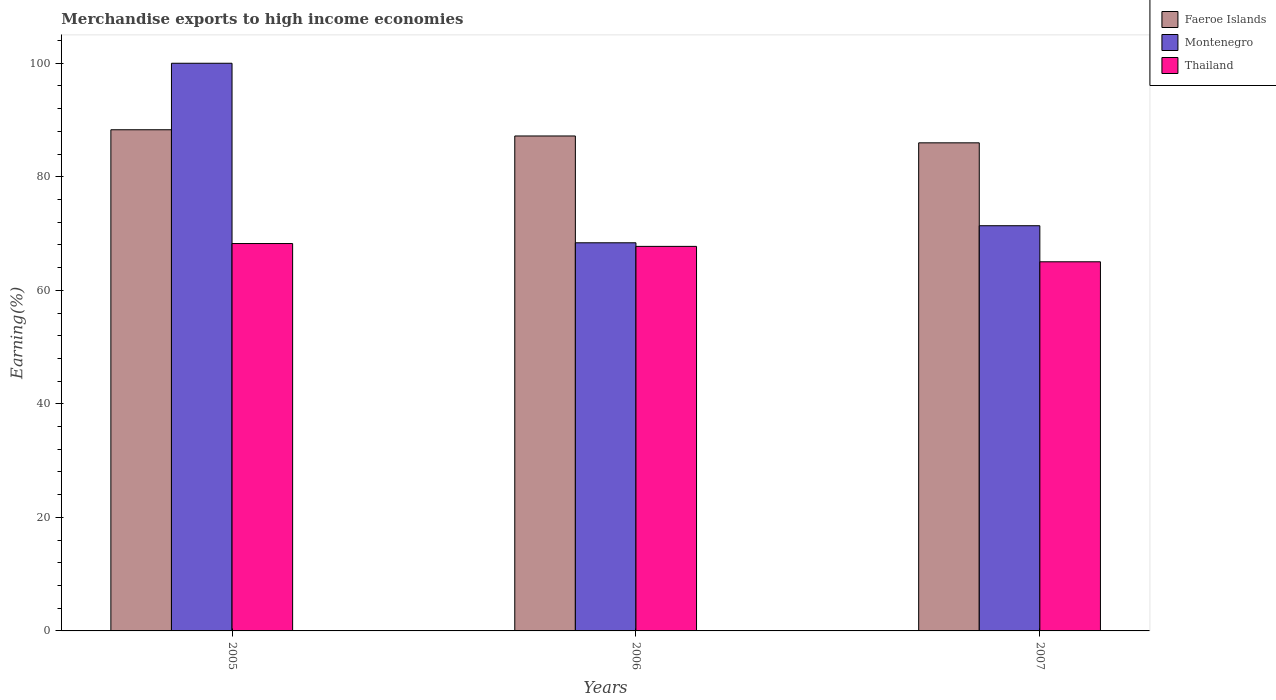How many groups of bars are there?
Keep it short and to the point. 3. What is the label of the 3rd group of bars from the left?
Offer a very short reply. 2007. In how many cases, is the number of bars for a given year not equal to the number of legend labels?
Offer a very short reply. 0. What is the percentage of amount earned from merchandise exports in Montenegro in 2005?
Offer a terse response. 100. Across all years, what is the maximum percentage of amount earned from merchandise exports in Faeroe Islands?
Ensure brevity in your answer.  88.29. Across all years, what is the minimum percentage of amount earned from merchandise exports in Montenegro?
Your answer should be very brief. 68.37. In which year was the percentage of amount earned from merchandise exports in Thailand maximum?
Offer a very short reply. 2005. In which year was the percentage of amount earned from merchandise exports in Faeroe Islands minimum?
Provide a succinct answer. 2007. What is the total percentage of amount earned from merchandise exports in Faeroe Islands in the graph?
Your answer should be very brief. 261.46. What is the difference between the percentage of amount earned from merchandise exports in Thailand in 2005 and that in 2007?
Your answer should be compact. 3.22. What is the difference between the percentage of amount earned from merchandise exports in Faeroe Islands in 2005 and the percentage of amount earned from merchandise exports in Montenegro in 2006?
Give a very brief answer. 19.91. What is the average percentage of amount earned from merchandise exports in Montenegro per year?
Offer a very short reply. 79.92. In the year 2006, what is the difference between the percentage of amount earned from merchandise exports in Montenegro and percentage of amount earned from merchandise exports in Thailand?
Your response must be concise. 0.63. What is the ratio of the percentage of amount earned from merchandise exports in Thailand in 2006 to that in 2007?
Your answer should be very brief. 1.04. Is the difference between the percentage of amount earned from merchandise exports in Montenegro in 2006 and 2007 greater than the difference between the percentage of amount earned from merchandise exports in Thailand in 2006 and 2007?
Keep it short and to the point. No. What is the difference between the highest and the second highest percentage of amount earned from merchandise exports in Faeroe Islands?
Provide a succinct answer. 1.1. What is the difference between the highest and the lowest percentage of amount earned from merchandise exports in Faeroe Islands?
Your answer should be very brief. 2.3. What does the 3rd bar from the left in 2007 represents?
Your answer should be compact. Thailand. What does the 3rd bar from the right in 2007 represents?
Offer a terse response. Faeroe Islands. How many bars are there?
Offer a very short reply. 9. What is the difference between two consecutive major ticks on the Y-axis?
Provide a short and direct response. 20. Are the values on the major ticks of Y-axis written in scientific E-notation?
Make the answer very short. No. Does the graph contain any zero values?
Your answer should be very brief. No. Where does the legend appear in the graph?
Your answer should be very brief. Top right. How many legend labels are there?
Make the answer very short. 3. What is the title of the graph?
Your answer should be compact. Merchandise exports to high income economies. What is the label or title of the Y-axis?
Your answer should be compact. Earning(%). What is the Earning(%) of Faeroe Islands in 2005?
Ensure brevity in your answer.  88.29. What is the Earning(%) in Montenegro in 2005?
Offer a very short reply. 100. What is the Earning(%) in Thailand in 2005?
Offer a very short reply. 68.24. What is the Earning(%) in Faeroe Islands in 2006?
Your answer should be very brief. 87.19. What is the Earning(%) of Montenegro in 2006?
Keep it short and to the point. 68.37. What is the Earning(%) in Thailand in 2006?
Offer a very short reply. 67.74. What is the Earning(%) in Faeroe Islands in 2007?
Your answer should be compact. 85.98. What is the Earning(%) in Montenegro in 2007?
Provide a succinct answer. 71.38. What is the Earning(%) in Thailand in 2007?
Give a very brief answer. 65.03. Across all years, what is the maximum Earning(%) of Faeroe Islands?
Keep it short and to the point. 88.29. Across all years, what is the maximum Earning(%) in Montenegro?
Your response must be concise. 100. Across all years, what is the maximum Earning(%) of Thailand?
Make the answer very short. 68.24. Across all years, what is the minimum Earning(%) in Faeroe Islands?
Offer a terse response. 85.98. Across all years, what is the minimum Earning(%) in Montenegro?
Offer a very short reply. 68.37. Across all years, what is the minimum Earning(%) of Thailand?
Your answer should be very brief. 65.03. What is the total Earning(%) of Faeroe Islands in the graph?
Offer a very short reply. 261.46. What is the total Earning(%) in Montenegro in the graph?
Your answer should be compact. 239.75. What is the total Earning(%) in Thailand in the graph?
Offer a very short reply. 201.01. What is the difference between the Earning(%) of Faeroe Islands in 2005 and that in 2006?
Your response must be concise. 1.1. What is the difference between the Earning(%) in Montenegro in 2005 and that in 2006?
Your response must be concise. 31.63. What is the difference between the Earning(%) of Thailand in 2005 and that in 2006?
Keep it short and to the point. 0.5. What is the difference between the Earning(%) of Faeroe Islands in 2005 and that in 2007?
Provide a short and direct response. 2.3. What is the difference between the Earning(%) in Montenegro in 2005 and that in 2007?
Provide a succinct answer. 28.62. What is the difference between the Earning(%) in Thailand in 2005 and that in 2007?
Provide a succinct answer. 3.22. What is the difference between the Earning(%) of Faeroe Islands in 2006 and that in 2007?
Provide a succinct answer. 1.21. What is the difference between the Earning(%) in Montenegro in 2006 and that in 2007?
Offer a very short reply. -3.01. What is the difference between the Earning(%) in Thailand in 2006 and that in 2007?
Make the answer very short. 2.72. What is the difference between the Earning(%) in Faeroe Islands in 2005 and the Earning(%) in Montenegro in 2006?
Your answer should be very brief. 19.91. What is the difference between the Earning(%) of Faeroe Islands in 2005 and the Earning(%) of Thailand in 2006?
Give a very brief answer. 20.54. What is the difference between the Earning(%) of Montenegro in 2005 and the Earning(%) of Thailand in 2006?
Provide a succinct answer. 32.26. What is the difference between the Earning(%) of Faeroe Islands in 2005 and the Earning(%) of Montenegro in 2007?
Your answer should be very brief. 16.91. What is the difference between the Earning(%) of Faeroe Islands in 2005 and the Earning(%) of Thailand in 2007?
Provide a succinct answer. 23.26. What is the difference between the Earning(%) in Montenegro in 2005 and the Earning(%) in Thailand in 2007?
Make the answer very short. 34.97. What is the difference between the Earning(%) in Faeroe Islands in 2006 and the Earning(%) in Montenegro in 2007?
Ensure brevity in your answer.  15.81. What is the difference between the Earning(%) in Faeroe Islands in 2006 and the Earning(%) in Thailand in 2007?
Give a very brief answer. 22.16. What is the difference between the Earning(%) in Montenegro in 2006 and the Earning(%) in Thailand in 2007?
Give a very brief answer. 3.35. What is the average Earning(%) of Faeroe Islands per year?
Offer a terse response. 87.15. What is the average Earning(%) in Montenegro per year?
Your answer should be very brief. 79.92. What is the average Earning(%) of Thailand per year?
Make the answer very short. 67. In the year 2005, what is the difference between the Earning(%) of Faeroe Islands and Earning(%) of Montenegro?
Make the answer very short. -11.71. In the year 2005, what is the difference between the Earning(%) in Faeroe Islands and Earning(%) in Thailand?
Give a very brief answer. 20.04. In the year 2005, what is the difference between the Earning(%) in Montenegro and Earning(%) in Thailand?
Offer a terse response. 31.76. In the year 2006, what is the difference between the Earning(%) of Faeroe Islands and Earning(%) of Montenegro?
Offer a very short reply. 18.82. In the year 2006, what is the difference between the Earning(%) in Faeroe Islands and Earning(%) in Thailand?
Your answer should be compact. 19.45. In the year 2006, what is the difference between the Earning(%) in Montenegro and Earning(%) in Thailand?
Your response must be concise. 0.63. In the year 2007, what is the difference between the Earning(%) of Faeroe Islands and Earning(%) of Montenegro?
Your answer should be very brief. 14.6. In the year 2007, what is the difference between the Earning(%) in Faeroe Islands and Earning(%) in Thailand?
Your answer should be compact. 20.96. In the year 2007, what is the difference between the Earning(%) of Montenegro and Earning(%) of Thailand?
Keep it short and to the point. 6.35. What is the ratio of the Earning(%) in Faeroe Islands in 2005 to that in 2006?
Your response must be concise. 1.01. What is the ratio of the Earning(%) of Montenegro in 2005 to that in 2006?
Keep it short and to the point. 1.46. What is the ratio of the Earning(%) in Thailand in 2005 to that in 2006?
Your answer should be compact. 1.01. What is the ratio of the Earning(%) of Faeroe Islands in 2005 to that in 2007?
Provide a short and direct response. 1.03. What is the ratio of the Earning(%) of Montenegro in 2005 to that in 2007?
Offer a very short reply. 1.4. What is the ratio of the Earning(%) of Thailand in 2005 to that in 2007?
Offer a terse response. 1.05. What is the ratio of the Earning(%) of Montenegro in 2006 to that in 2007?
Your response must be concise. 0.96. What is the ratio of the Earning(%) in Thailand in 2006 to that in 2007?
Provide a short and direct response. 1.04. What is the difference between the highest and the second highest Earning(%) in Faeroe Islands?
Give a very brief answer. 1.1. What is the difference between the highest and the second highest Earning(%) of Montenegro?
Provide a succinct answer. 28.62. What is the difference between the highest and the second highest Earning(%) of Thailand?
Your answer should be very brief. 0.5. What is the difference between the highest and the lowest Earning(%) in Faeroe Islands?
Provide a short and direct response. 2.3. What is the difference between the highest and the lowest Earning(%) in Montenegro?
Your answer should be compact. 31.63. What is the difference between the highest and the lowest Earning(%) of Thailand?
Provide a short and direct response. 3.22. 